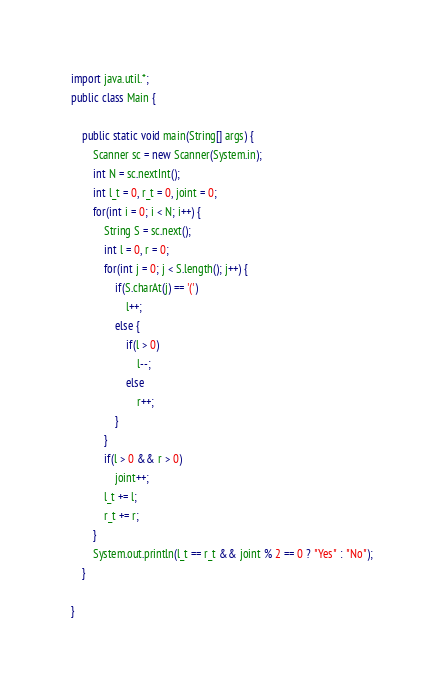<code> <loc_0><loc_0><loc_500><loc_500><_Java_>import java.util.*;
public class Main {

	public static void main(String[] args) {
		Scanner sc = new Scanner(System.in);
		int N = sc.nextInt();
		int l_t = 0, r_t = 0, joint = 0;
		for(int i = 0; i < N; i++) {
			String S = sc.next();
			int l = 0, r = 0;
			for(int j = 0; j < S.length(); j++) {
				if(S.charAt(j) == '(')
					l++;
				else {
					if(l > 0)
						l--;
					else
						r++;
				}
			}
			if(l > 0 && r > 0)
				joint++;
			l_t += l;
			r_t += r;
		}
		System.out.println(l_t == r_t && joint % 2 == 0 ? "Yes" : "No");
	}

}</code> 